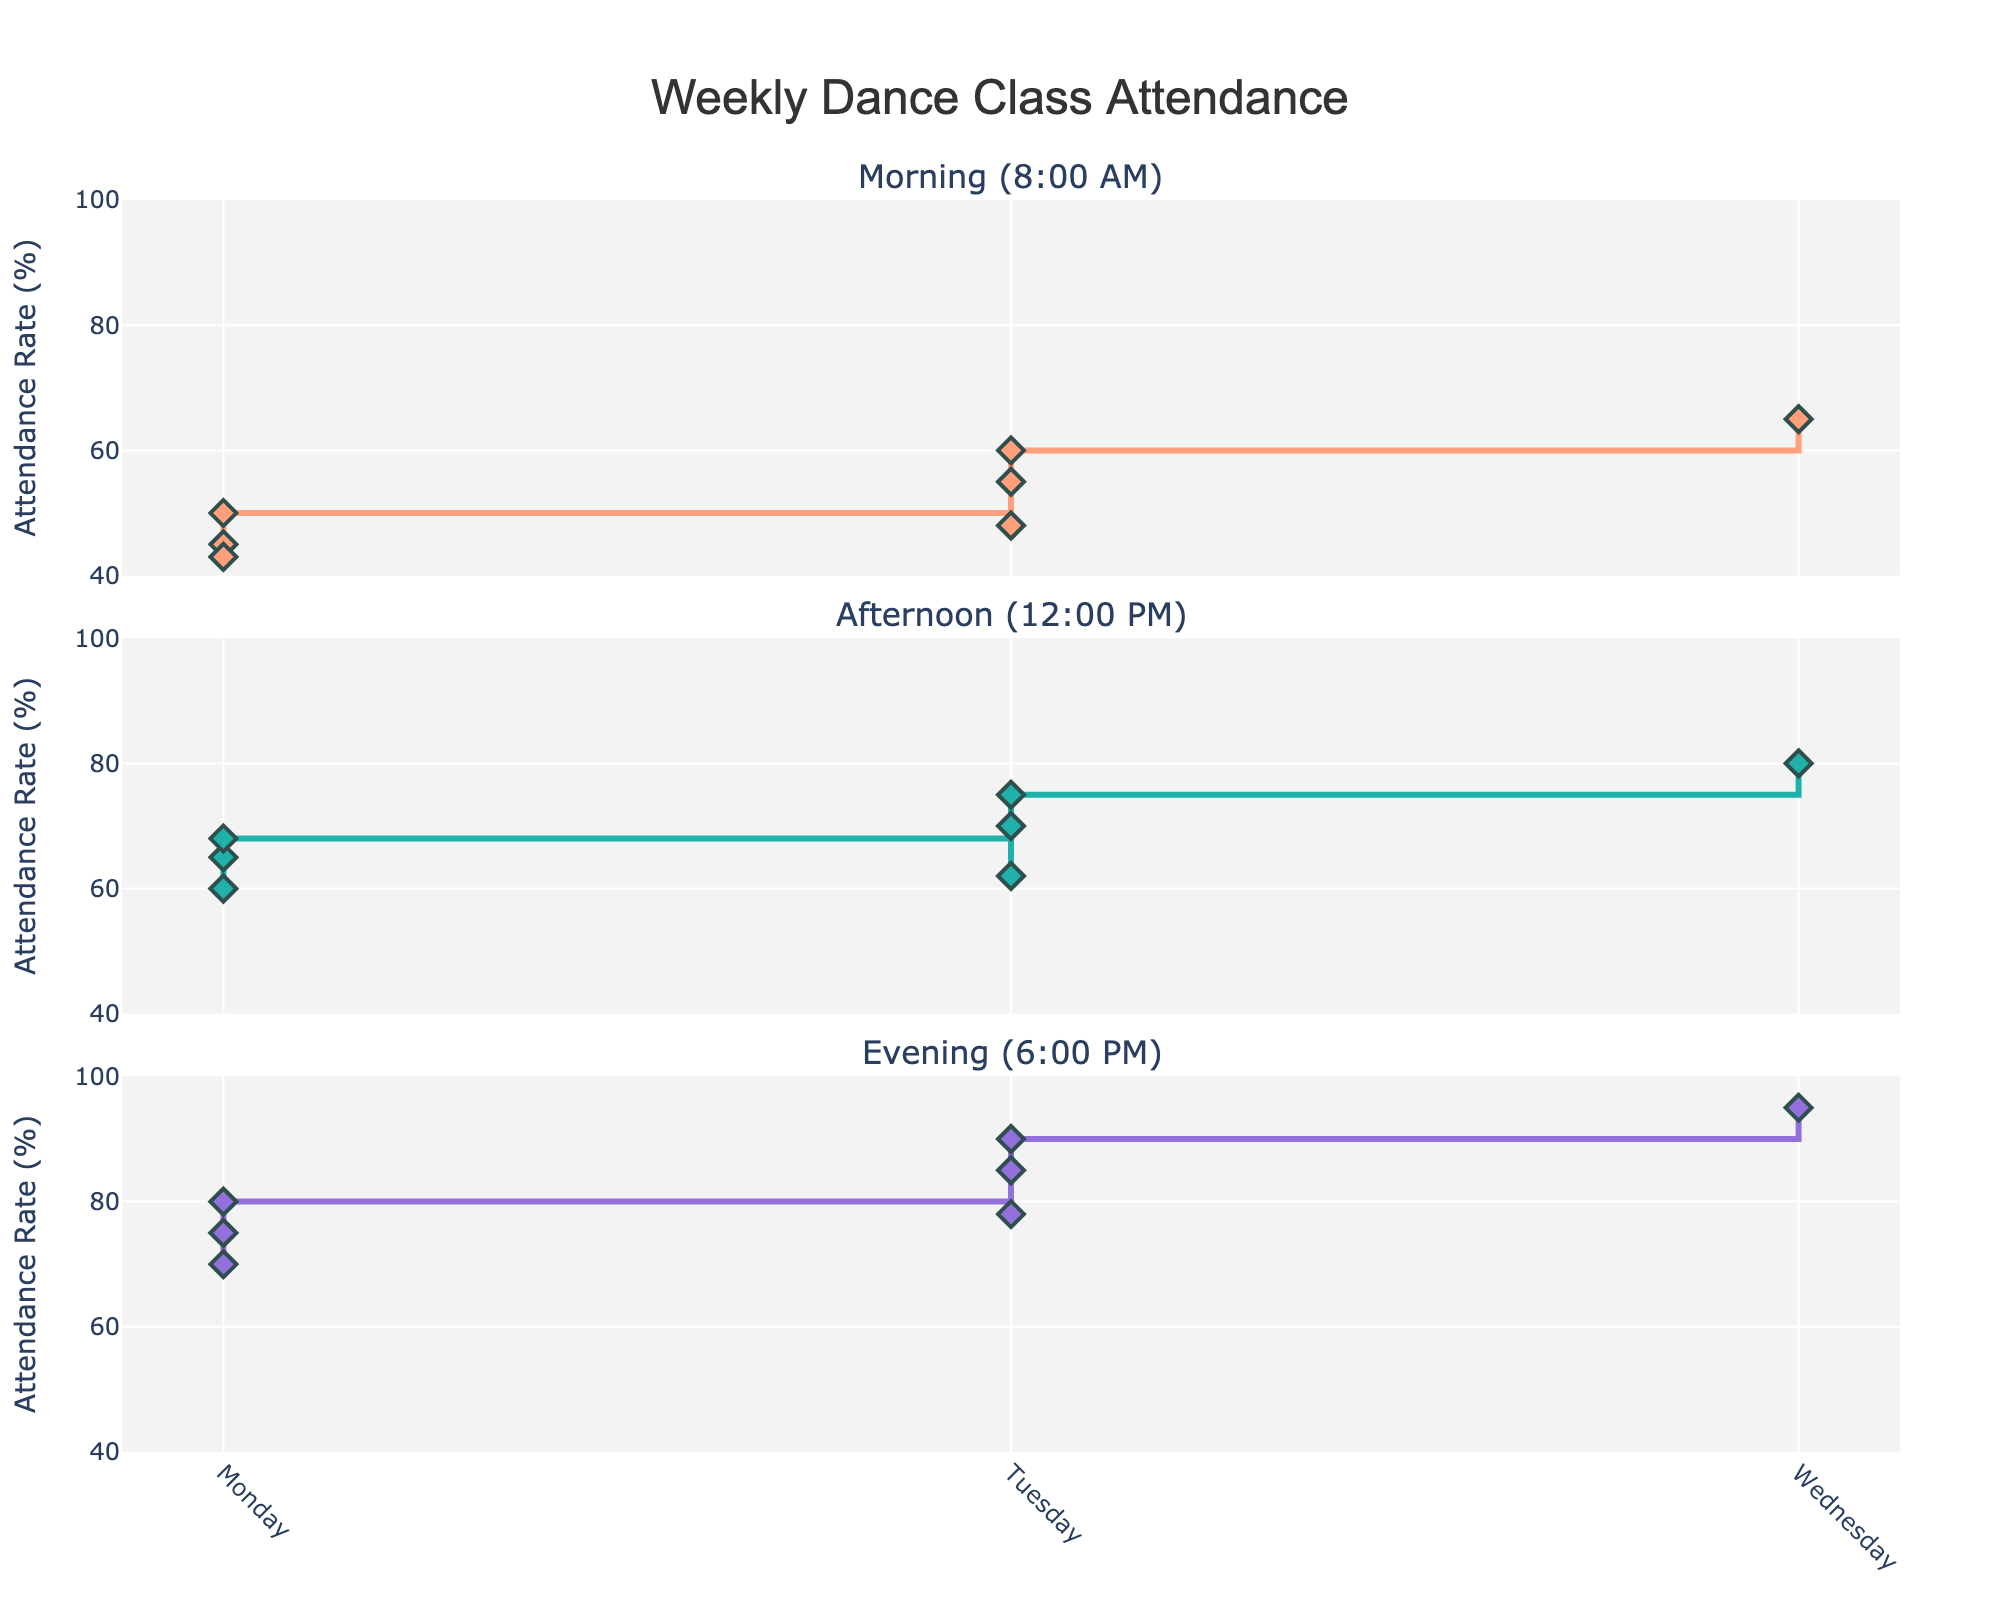What is the title of the figure? The title of the figure is displayed at the top and in larger, bold font. It reads "Weekly Dance Class Attendance".
Answer: Weekly Dance Class Attendance Which time slot has the lowest attendance rate on Monday? Referring to the first subplot for Monday, the time slot with the lowest attendance rate is at 8:00 AM.
Answer: 8:00 AM How does the attendance rate trend from Monday to Sunday in the 6:00 PM classes? In the evening slot (6:00 PM), the attendance rate consistently increases from Monday (75%) to Sunday (95%).
Answer: Increases What is the average attendance rate for the 12:00 PM classes over the week? Sum up the attendance rates for each day at 12:00 PM (60 + 65 + 68 + 62 + 70 + 75 + 80) which equals 480, then divide by 7 days to get the average.
Answer: (60 + 65 + 68 + 62 + 70 + 75 + 80) / 7 = 68.57 On which day do all three timeslots have the highest attendance rates? By examining all three subplots, Sunday shows the highest attendance rates for 8:00 AM (65%), 12:00 PM (80%), and 6:00 PM (95%).
Answer: Sunday What is the range of attendance rates for the 8:00 AM timeslot from Monday to Sunday? The range is the difference between the highest (Sunday, 65%) and the lowest (Tuesday, 43%) attendance rates.
Answer: 65% - 43% = 22% Does the attendance rate at 12:00 PM on Wednesday exceed that of Monday? Comparing the two values, Wednesday's 12:00 PM class has a rate of 68%, which exceeds Monday's 60%.
Answer: Yes 